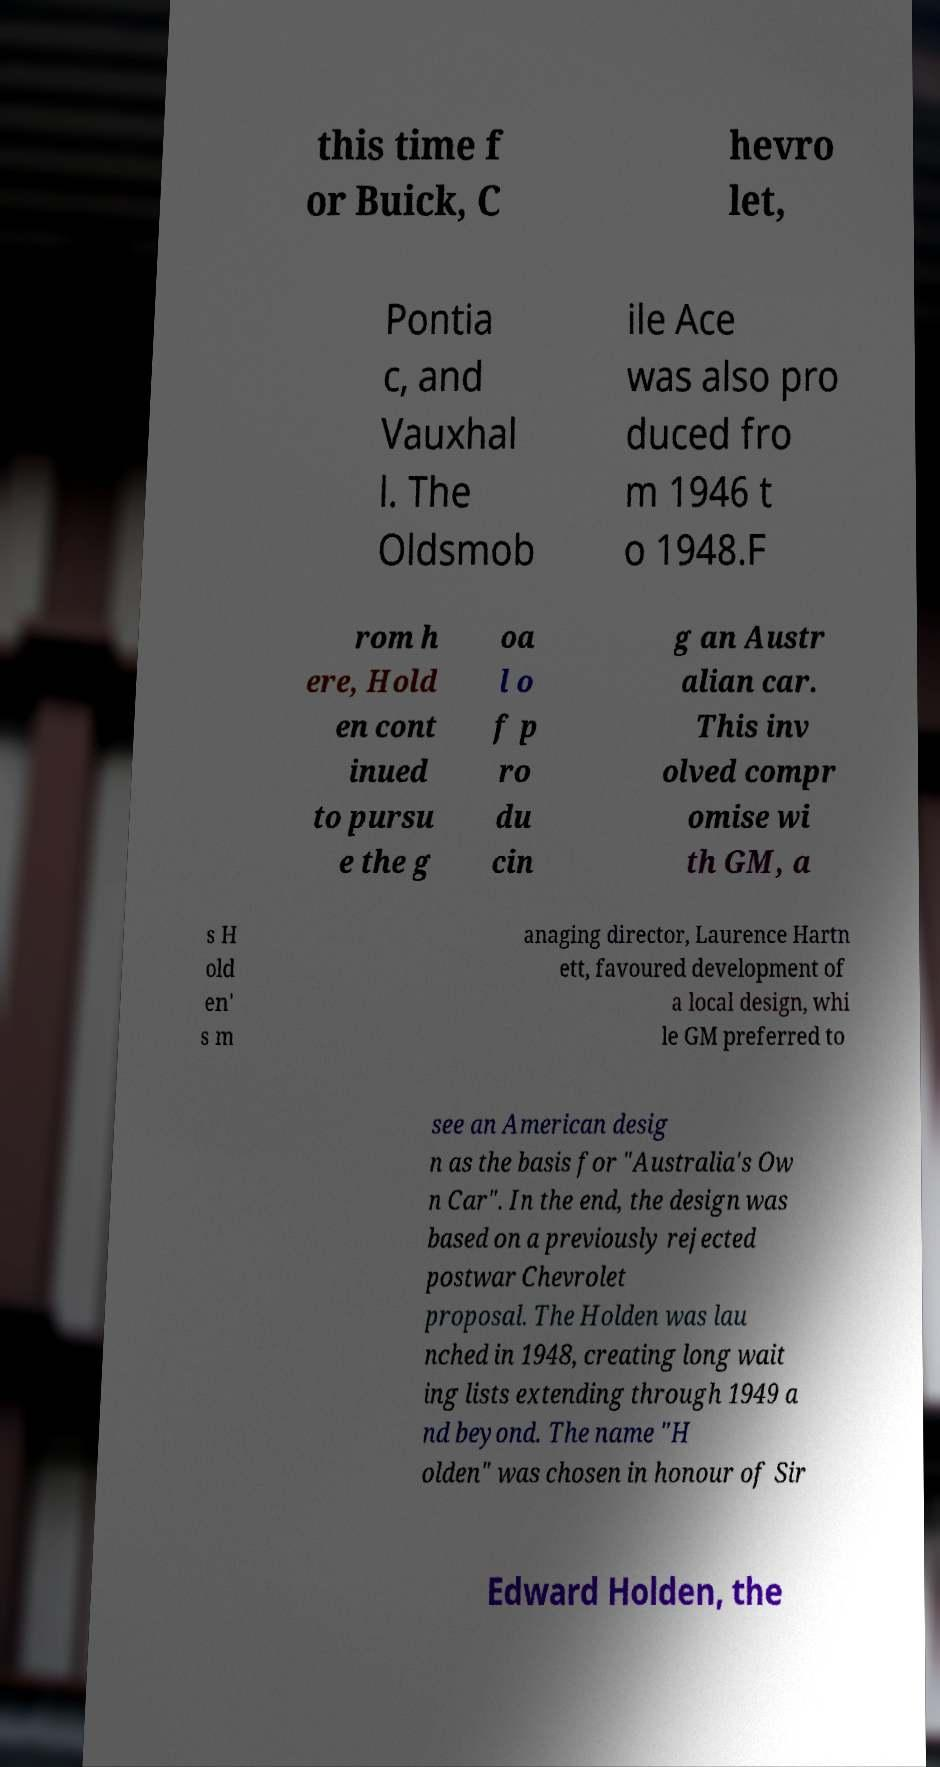Please identify and transcribe the text found in this image. this time f or Buick, C hevro let, Pontia c, and Vauxhal l. The Oldsmob ile Ace was also pro duced fro m 1946 t o 1948.F rom h ere, Hold en cont inued to pursu e the g oa l o f p ro du cin g an Austr alian car. This inv olved compr omise wi th GM, a s H old en' s m anaging director, Laurence Hartn ett, favoured development of a local design, whi le GM preferred to see an American desig n as the basis for "Australia's Ow n Car". In the end, the design was based on a previously rejected postwar Chevrolet proposal. The Holden was lau nched in 1948, creating long wait ing lists extending through 1949 a nd beyond. The name "H olden" was chosen in honour of Sir Edward Holden, the 